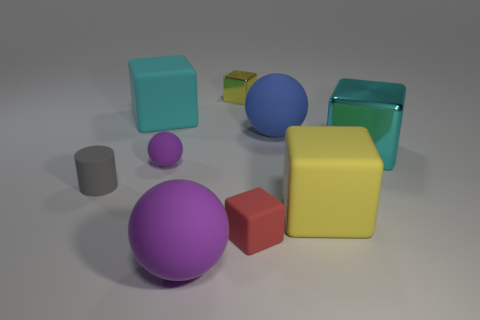Subtract all red cubes. How many cubes are left? 4 Subtract all brown cubes. Subtract all red cylinders. How many cubes are left? 5 Add 1 rubber spheres. How many objects exist? 10 Subtract all cylinders. How many objects are left? 8 Add 8 big red objects. How many big red objects exist? 8 Subtract 0 blue cubes. How many objects are left? 9 Subtract all big cyan things. Subtract all small yellow rubber things. How many objects are left? 7 Add 1 tiny spheres. How many tiny spheres are left? 2 